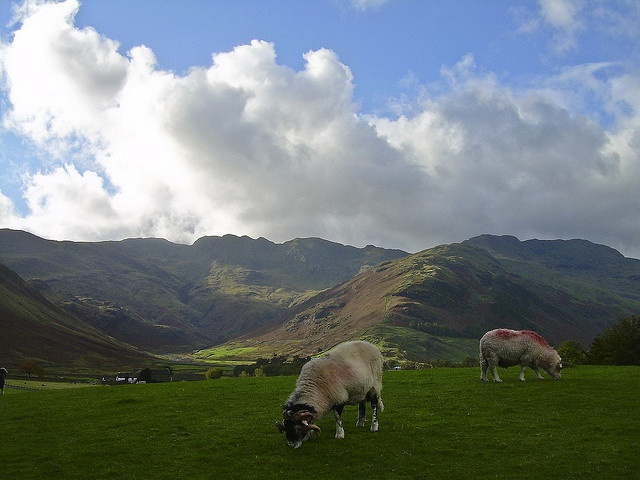Describe the objects in this image and their specific colors. I can see sheep in darkgray, black, and gray tones and sheep in darkgray, black, gray, darkgreen, and maroon tones in this image. 